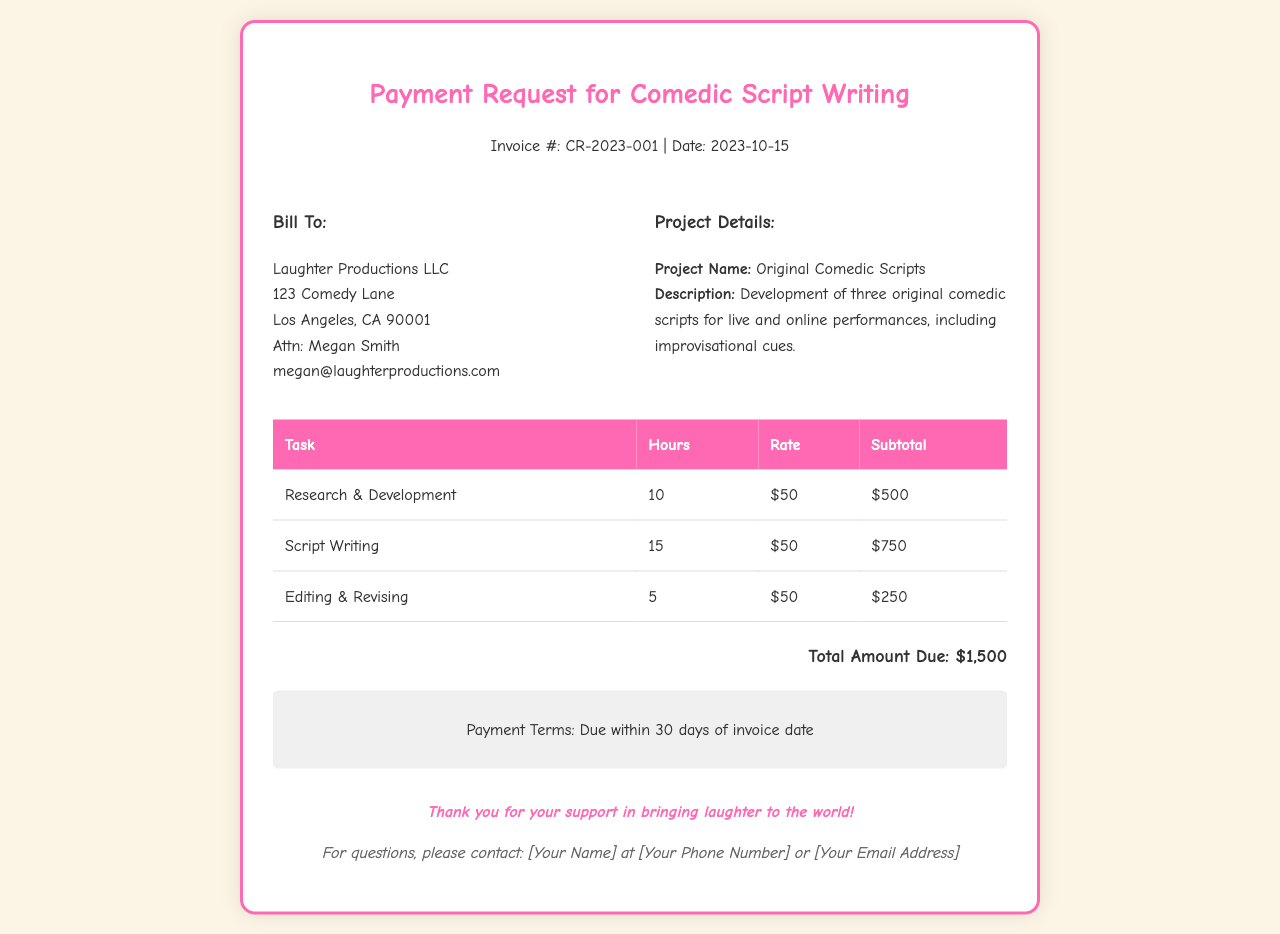What is the invoice number? The invoice number is specified in the header section of the document, which states "Invoice #: CR-2023-001".
Answer: CR-2023-001 What is the date of the invoice? The date is also found in the header section, right next to the invoice number, which indicates "Date: 2023-10-15".
Answer: 2023-10-15 Who is the billing company? The billing company name is found in the "Bill To" section, which lists "Laughter Productions LLC".
Answer: Laughter Productions LLC How many hours were spent on Script Writing? The hours for Script Writing are detailed in the task table, indicating "15" hours worked.
Answer: 15 What is the hourly rate for the services provided? The hourly rate is mentioned in every task row, showing that it is "$50".
Answer: $50 What is the total amount due? The total amount is clearly mentioned towards the end of the invoice, stating "Total Amount Due: $1,500".
Answer: $1,500 What task required the least amount of hours? By reviewing the tasks in the table, "Editing & Revising" is the task with the least hours, which is "5".
Answer: 5 What is the payment term? The payment terms are outlined in a specific section stating "Payment Terms: Due within 30 days of invoice date".
Answer: 30 days What project name is mentioned in the invoice? The project name is listed in the "Project Details" section as "Original Comedic Scripts".
Answer: Original Comedic Scripts 